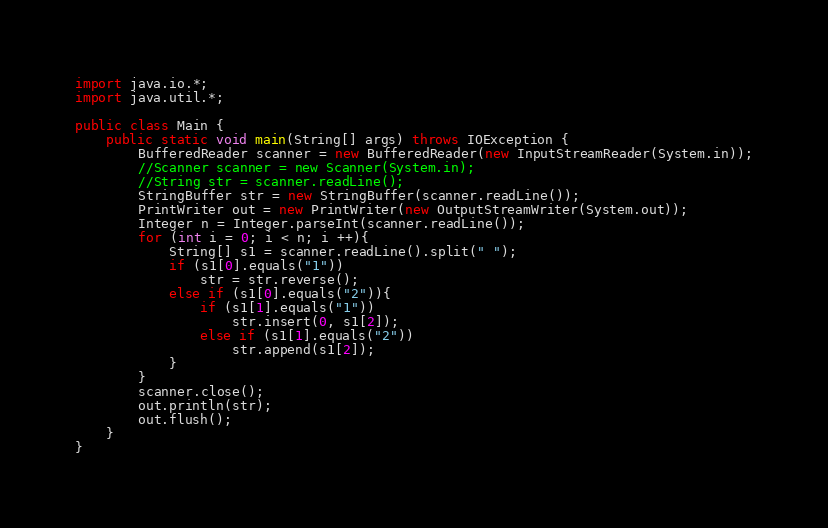<code> <loc_0><loc_0><loc_500><loc_500><_Java_>import java.io.*;
import java.util.*;

public class Main {
    public static void main(String[] args) throws IOException {
        BufferedReader scanner = new BufferedReader(new InputStreamReader(System.in));
        //Scanner scanner = new Scanner(System.in);
        //String str = scanner.readLine();
        StringBuffer str = new StringBuffer(scanner.readLine());
        PrintWriter out = new PrintWriter(new OutputStreamWriter(System.out));
        Integer n = Integer.parseInt(scanner.readLine());
        for (int i = 0; i < n; i ++){
            String[] s1 = scanner.readLine().split(" ");
            if (s1[0].equals("1"))
                str = str.reverse();
            else if (s1[0].equals("2")){
                if (s1[1].equals("1"))
                    str.insert(0, s1[2]);
                else if (s1[1].equals("2"))
                    str.append(s1[2]);
            }
        }
        scanner.close();
        out.println(str);
        out.flush();
    }
}
</code> 